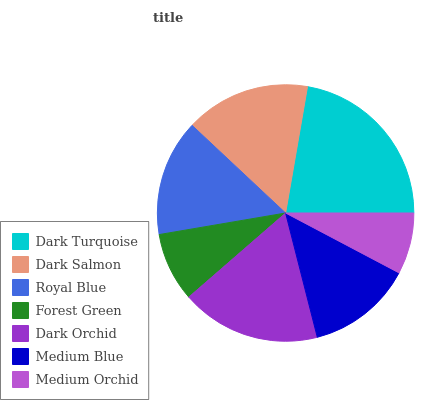Is Medium Orchid the minimum?
Answer yes or no. Yes. Is Dark Turquoise the maximum?
Answer yes or no. Yes. Is Dark Salmon the minimum?
Answer yes or no. No. Is Dark Salmon the maximum?
Answer yes or no. No. Is Dark Turquoise greater than Dark Salmon?
Answer yes or no. Yes. Is Dark Salmon less than Dark Turquoise?
Answer yes or no. Yes. Is Dark Salmon greater than Dark Turquoise?
Answer yes or no. No. Is Dark Turquoise less than Dark Salmon?
Answer yes or no. No. Is Royal Blue the high median?
Answer yes or no. Yes. Is Royal Blue the low median?
Answer yes or no. Yes. Is Forest Green the high median?
Answer yes or no. No. Is Dark Salmon the low median?
Answer yes or no. No. 